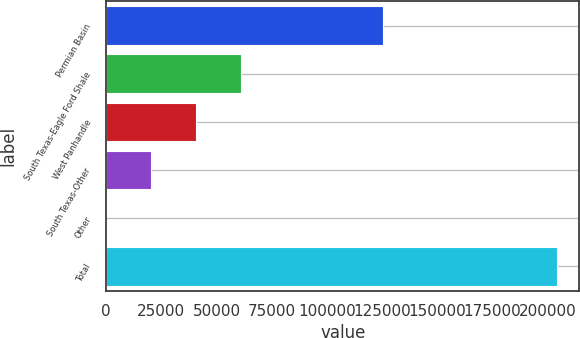<chart> <loc_0><loc_0><loc_500><loc_500><bar_chart><fcel>Permian Basin<fcel>South Texas-Eagle Ford Shale<fcel>West Panhandle<fcel>South Texas-Other<fcel>Other<fcel>Total<nl><fcel>125336<fcel>61226.9<fcel>40823.6<fcel>20420.3<fcel>17<fcel>204050<nl></chart> 